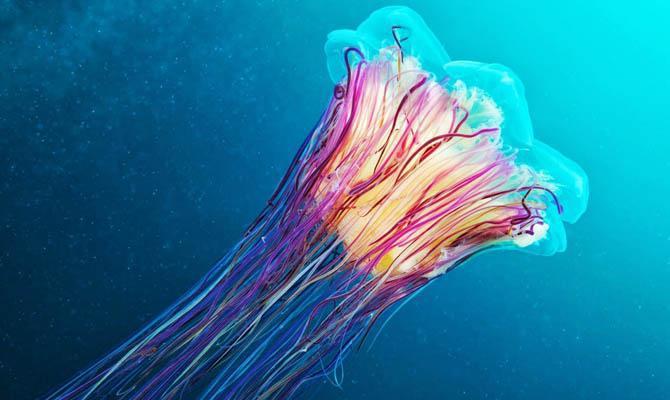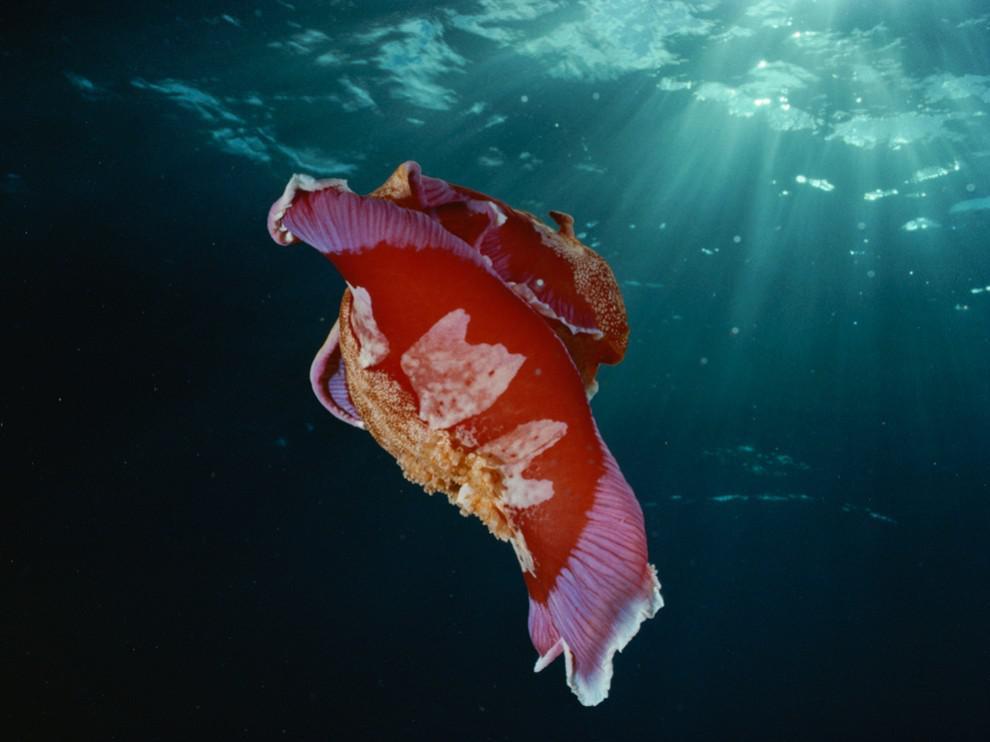The first image is the image on the left, the second image is the image on the right. Examine the images to the left and right. Is the description "At least one image shows a jellyfish with a folded appearance and no tendrils trailing from it." accurate? Answer yes or no. Yes. The first image is the image on the left, the second image is the image on the right. Analyze the images presented: Is the assertion "The sea creature in the image on the right looks like a cross between a clownfish and a jellyfish, with its bright orange body and white blotches." valid? Answer yes or no. Yes. 